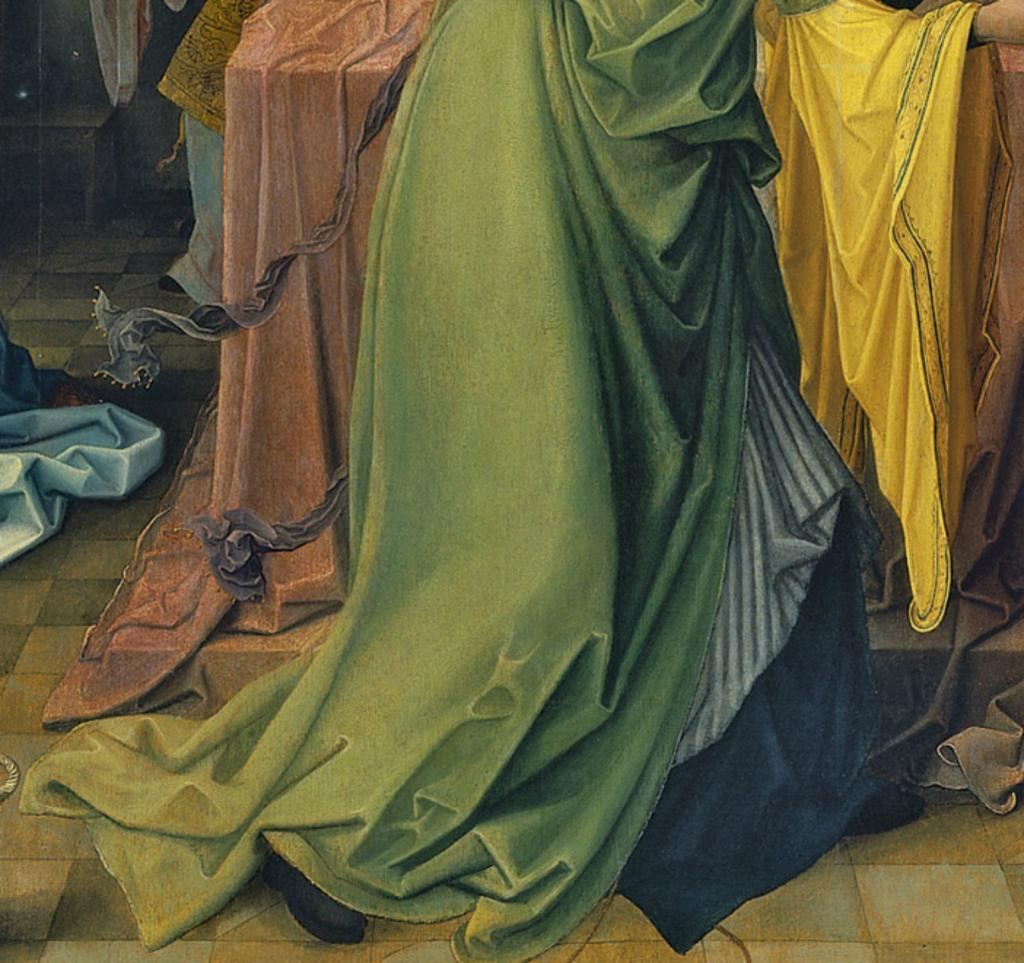What can be found on the floor in the image? There are different types of clothes on the floor in the image. What type of footwear is visible in the image? There are shoes visible in the image. What piece of furniture is present in the image? There is a table in the image. Can you describe the possible location where the image was taken? The image may have been taken in a hall. What type of flower is blooming on the table in the image? There is no flower present on the table in the image. What month is it in the image? The month cannot be determined from the image, as it does not contain any information about the time of year. 